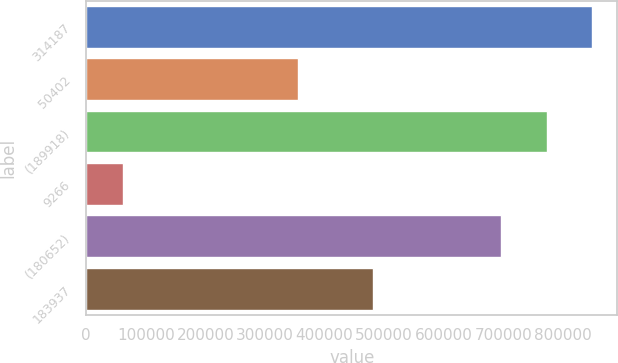Convert chart to OTSL. <chart><loc_0><loc_0><loc_500><loc_500><bar_chart><fcel>314187<fcel>50402<fcel>(189918)<fcel>9266<fcel>(180652)<fcel>183937<nl><fcel>848965<fcel>354637<fcel>772834<fcel>61499<fcel>696702<fcel>480751<nl></chart> 